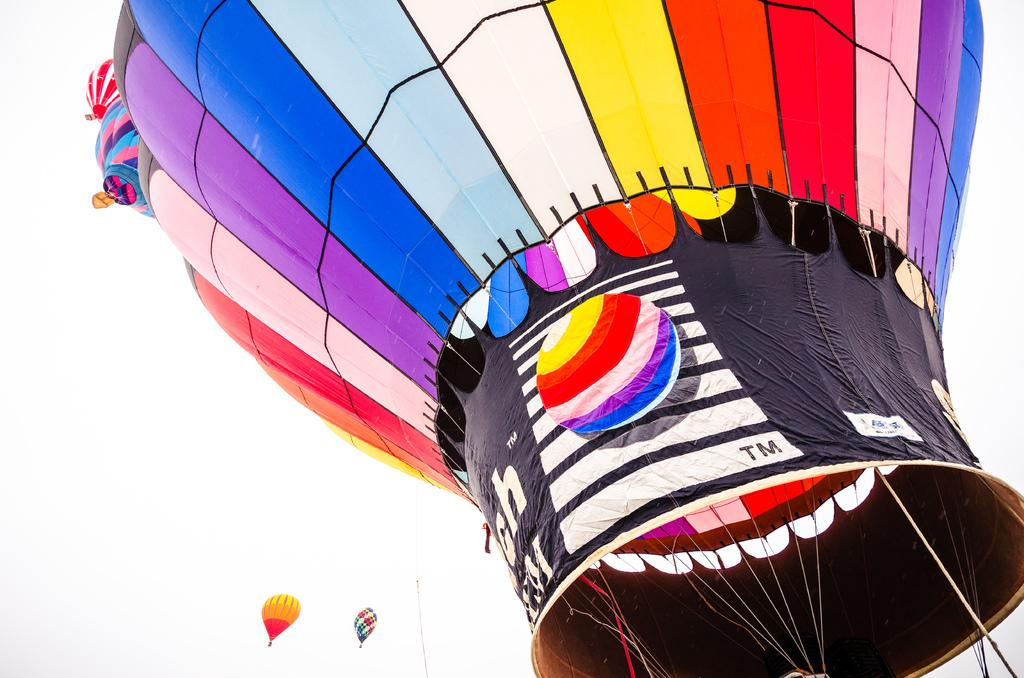How many hot air balloons are in the image? There are three hot air balloons in the image. What colors can be seen on the hot air balloons? The hot air balloons are in blue, pink, white, yellow, red, orange, and black colors. What is visible in the background of the image? The sky is visible in the background of the image. What type of argument is taking place between the hot air balloons in the image? There is no argument taking place between the hot air balloons in the image, as they are inanimate objects. 